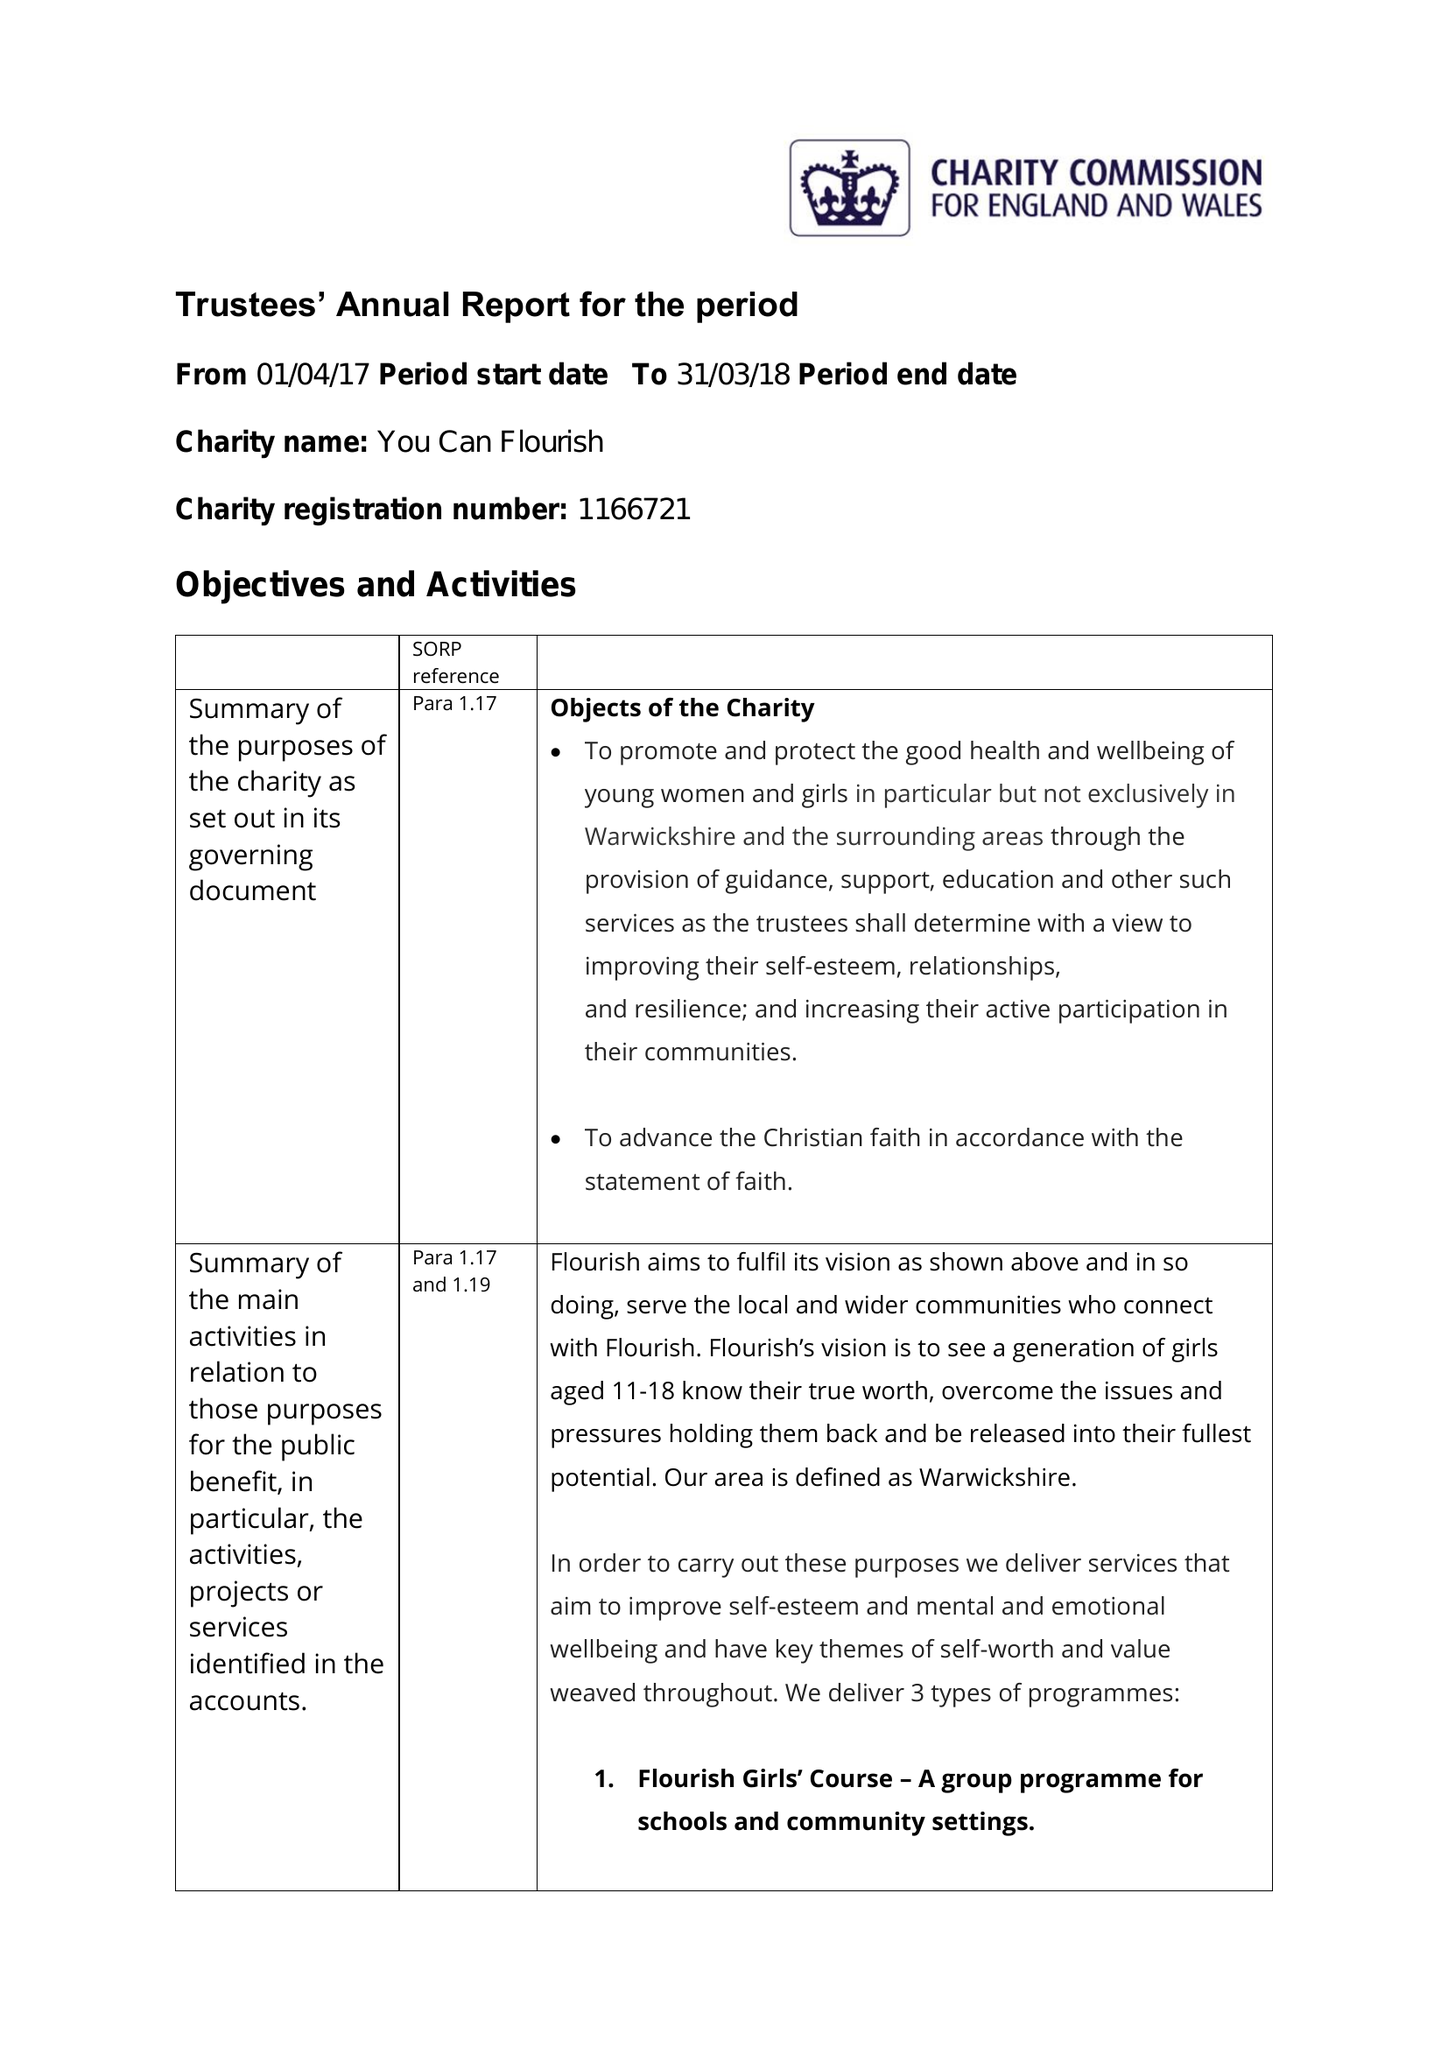What is the value for the address__postcode?
Answer the question using a single word or phrase. CV31 3RZ 